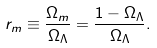<formula> <loc_0><loc_0><loc_500><loc_500>r _ { m } \equiv \frac { \Omega _ { m } } { \Omega _ { \Lambda } } = \frac { 1 - \Omega _ { \Lambda } } { \Omega _ { \Lambda } } .</formula> 